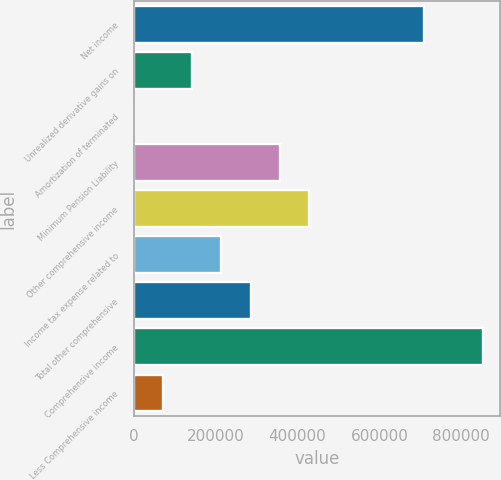Convert chart to OTSL. <chart><loc_0><loc_0><loc_500><loc_500><bar_chart><fcel>Net income<fcel>Unrealized derivative gains on<fcel>Amortization of terminated<fcel>Minimum Pension Liability<fcel>Other comprehensive income<fcel>Income tax expense related to<fcel>Total other comprehensive<fcel>Comprehensive income<fcel>Less Comprehensive income<nl><fcel>709889<fcel>142596<fcel>0.51<fcel>356489<fcel>427786<fcel>213893<fcel>285191<fcel>852484<fcel>71298.2<nl></chart> 